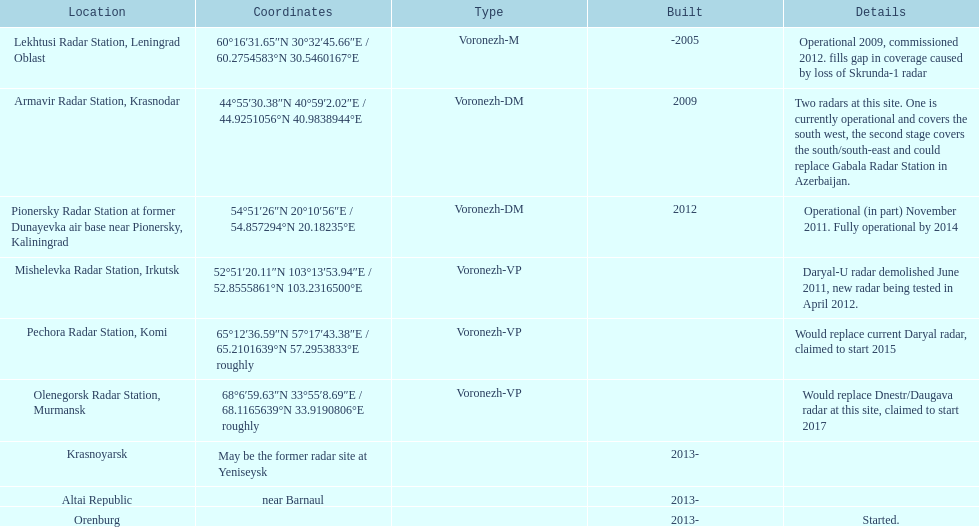What is the only spot having coordinates 60°16'3 Lekhtusi Radar Station, Leningrad Oblast. 